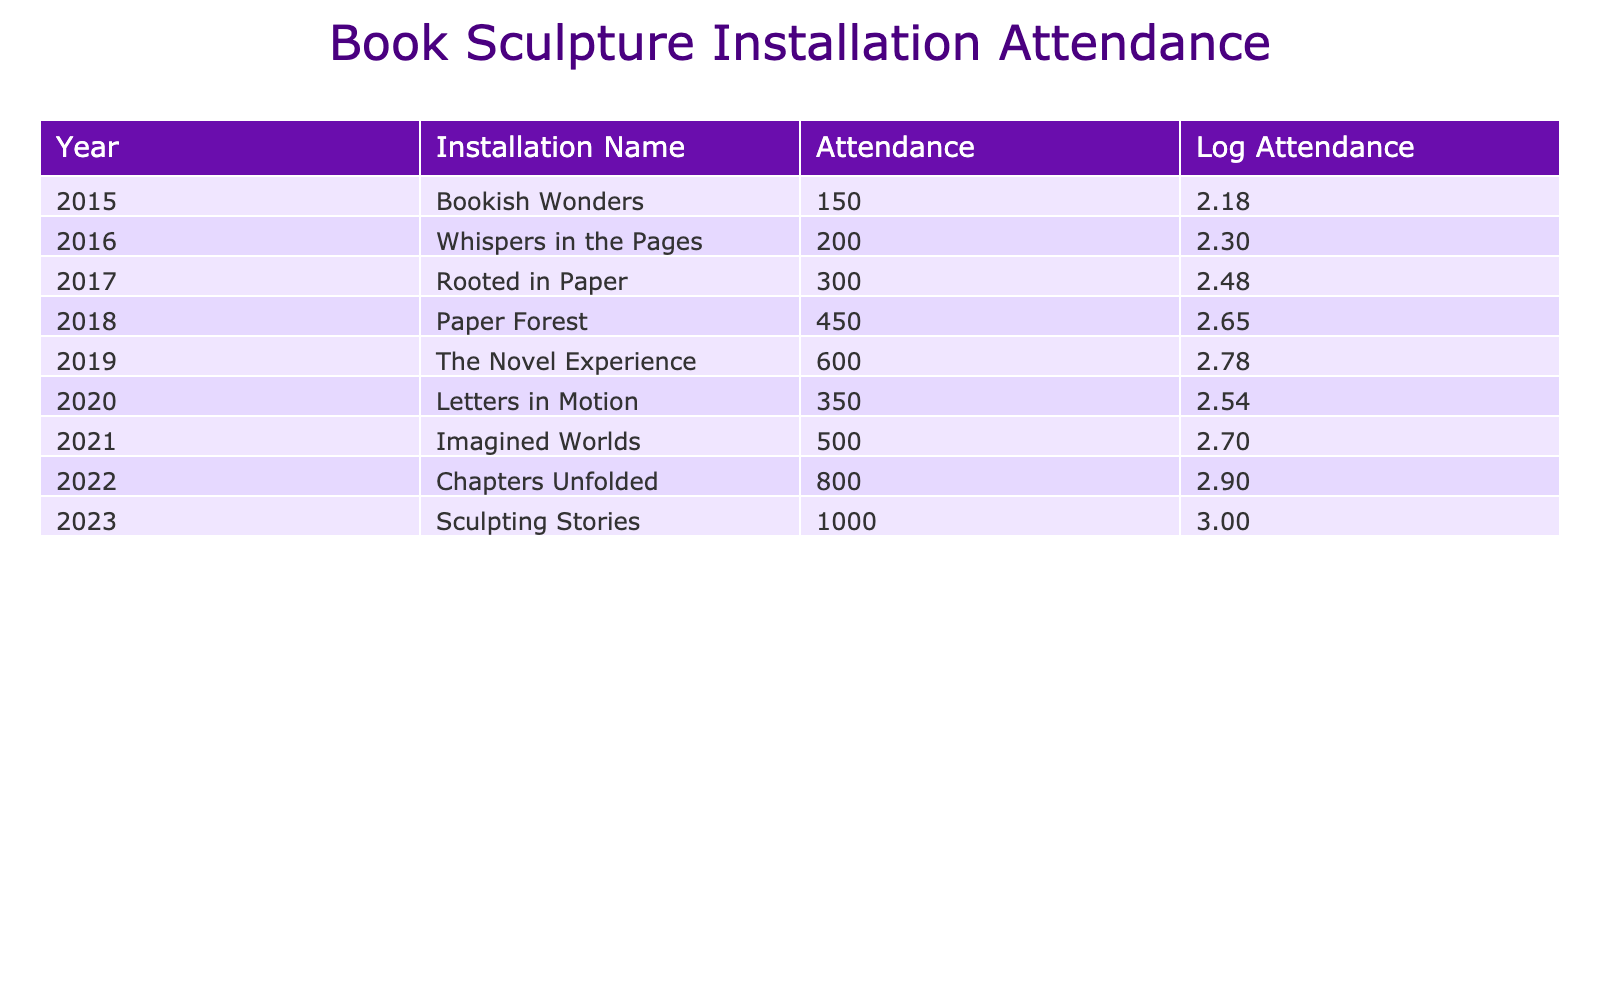What was the attendance for the installation "Imagined Worlds"? The table lists the attendance for each installation, and for "Imagined Worlds" in the year 2021, the attendance is given as 500.
Answer: 500 What year had the highest attendance? Looking through the table, the attendance figures increase over the years, with "Sculpting Stories" in 2023 having the highest attendance of 1000.
Answer: 2023 What is the difference in attendance between "Rooted in Paper" and "Letters in Motion"? The attendance for "Rooted in Paper" in 2017 is 300, and for "Letters in Motion" in 2020 it is 350. The difference is 350 - 300 = 50.
Answer: 50 What is the average attendance from 2015 to 2023? To find the average, we sum the attendance numbers: 150 + 200 + 300 + 450 + 600 + 350 + 500 + 800 + 1000 = 4350. Dividing by the 9 years gives us an average of 4350 / 9 = 483.33.
Answer: 483.33 Did attendance ever drop from one year to the next? Analyzing the attendance data year by year, from 2015 to 2023, we see an increase every year except from 2019 (600) to 2020 (350), where it dropped.
Answer: Yes What was the total attendance for installations from 2015 to 2019? Summing the attendance numbers from 2015 to 2019 gives us: 150 + 200 + 300 + 450 + 600 = 1700.
Answer: 1700 How does the logarithmic value for "Chapters Unfolded" compare to "The Novel Experience"? The attendance for "Chapters Unfolded" is 800, leading to a logarithmic value calculated as log10(800) approximately 2.90. For "The Novel Experience" with attendance of 600, it's log10(600) approximately 2.78. So, 2.90 > 2.78.
Answer: Chapters Unfolded has a higher logarithmic value What was the trend in attendance from 2015 to 2023? The attendance increased every year with no decreases from 2015 (150) to 2023 (1000), indicating a growing interest in the installations.
Answer: Increasing trend How many installations had an attendance of over 500? By examining the table, the installations with attendance over 500 are "Chapters Unfolded" (800) and "Sculpting Stories" (1000), resulting in a total of 2 installations.
Answer: 2 